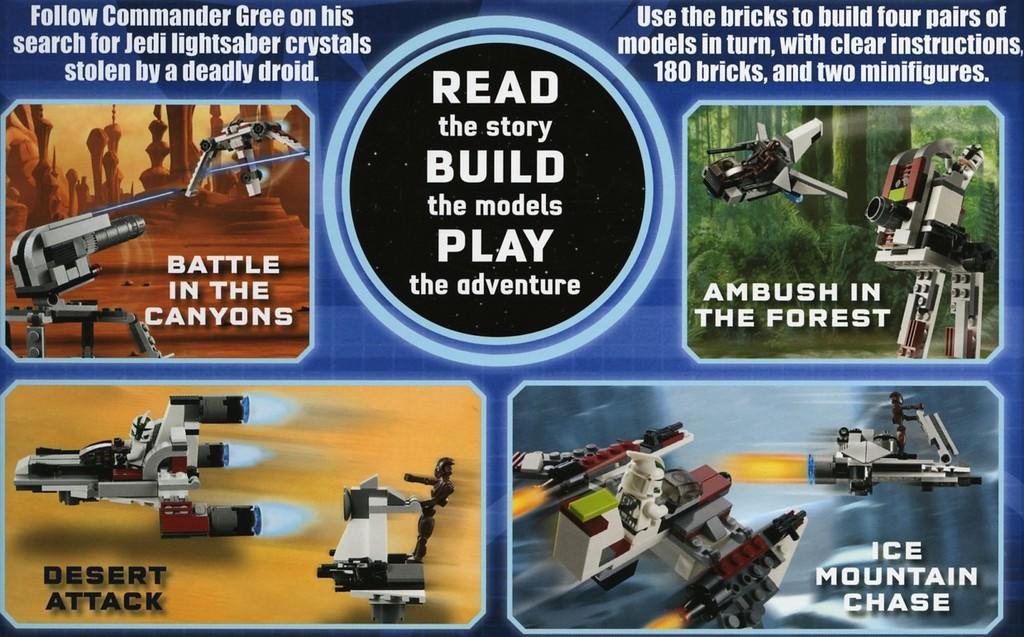Provide a one-sentence caption for the provided image. An advertisement for a science fiction based brick toy set. 